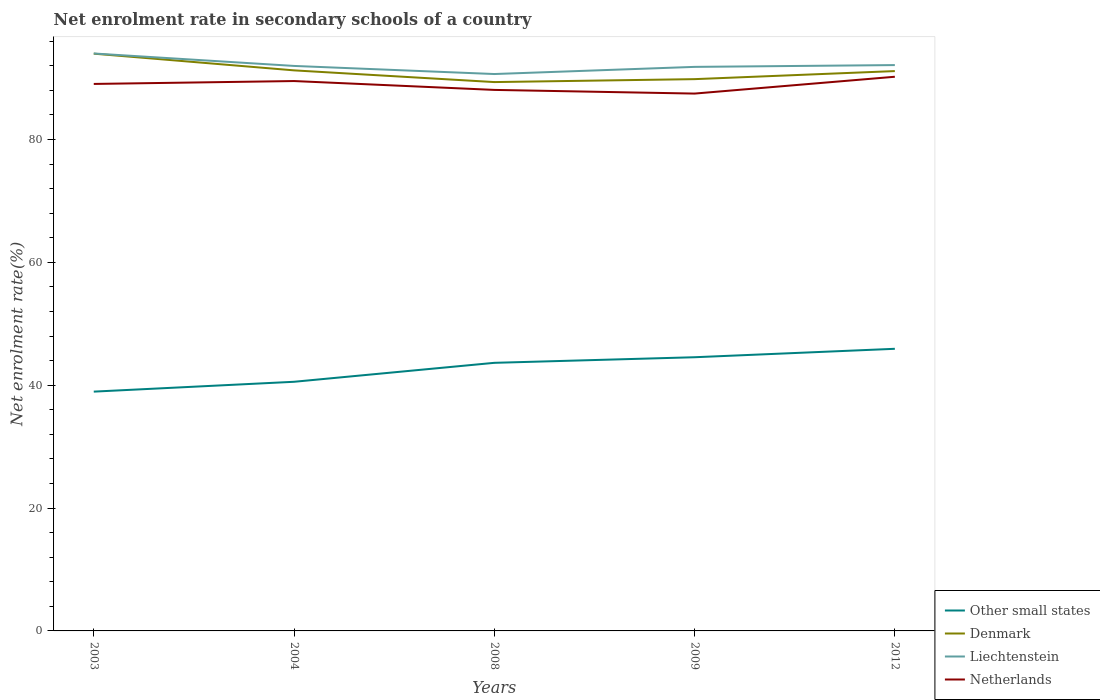How many different coloured lines are there?
Give a very brief answer. 4. Does the line corresponding to Denmark intersect with the line corresponding to Other small states?
Your answer should be very brief. No. Is the number of lines equal to the number of legend labels?
Offer a terse response. Yes. Across all years, what is the maximum net enrolment rate in secondary schools in Netherlands?
Give a very brief answer. 87.48. In which year was the net enrolment rate in secondary schools in Denmark maximum?
Provide a succinct answer. 2008. What is the total net enrolment rate in secondary schools in Netherlands in the graph?
Give a very brief answer. -1.17. What is the difference between the highest and the second highest net enrolment rate in secondary schools in Liechtenstein?
Make the answer very short. 3.35. How many lines are there?
Your answer should be compact. 4. What is the difference between two consecutive major ticks on the Y-axis?
Your answer should be compact. 20. Are the values on the major ticks of Y-axis written in scientific E-notation?
Give a very brief answer. No. Where does the legend appear in the graph?
Offer a terse response. Bottom right. What is the title of the graph?
Provide a succinct answer. Net enrolment rate in secondary schools of a country. Does "Benin" appear as one of the legend labels in the graph?
Your response must be concise. No. What is the label or title of the X-axis?
Give a very brief answer. Years. What is the label or title of the Y-axis?
Give a very brief answer. Net enrolment rate(%). What is the Net enrolment rate(%) of Other small states in 2003?
Give a very brief answer. 38.96. What is the Net enrolment rate(%) of Denmark in 2003?
Offer a very short reply. 93.98. What is the Net enrolment rate(%) in Liechtenstein in 2003?
Offer a terse response. 94.01. What is the Net enrolment rate(%) of Netherlands in 2003?
Ensure brevity in your answer.  89.05. What is the Net enrolment rate(%) in Other small states in 2004?
Your response must be concise. 40.56. What is the Net enrolment rate(%) of Denmark in 2004?
Keep it short and to the point. 91.26. What is the Net enrolment rate(%) of Liechtenstein in 2004?
Offer a terse response. 91.98. What is the Net enrolment rate(%) of Netherlands in 2004?
Keep it short and to the point. 89.52. What is the Net enrolment rate(%) in Other small states in 2008?
Give a very brief answer. 43.64. What is the Net enrolment rate(%) in Denmark in 2008?
Keep it short and to the point. 89.35. What is the Net enrolment rate(%) of Liechtenstein in 2008?
Make the answer very short. 90.66. What is the Net enrolment rate(%) of Netherlands in 2008?
Make the answer very short. 88.08. What is the Net enrolment rate(%) in Other small states in 2009?
Keep it short and to the point. 44.55. What is the Net enrolment rate(%) in Denmark in 2009?
Your answer should be very brief. 89.83. What is the Net enrolment rate(%) of Liechtenstein in 2009?
Offer a terse response. 91.83. What is the Net enrolment rate(%) in Netherlands in 2009?
Provide a succinct answer. 87.48. What is the Net enrolment rate(%) in Other small states in 2012?
Offer a terse response. 45.93. What is the Net enrolment rate(%) of Denmark in 2012?
Provide a short and direct response. 91.14. What is the Net enrolment rate(%) of Liechtenstein in 2012?
Keep it short and to the point. 92.12. What is the Net enrolment rate(%) in Netherlands in 2012?
Ensure brevity in your answer.  90.22. Across all years, what is the maximum Net enrolment rate(%) of Other small states?
Your answer should be compact. 45.93. Across all years, what is the maximum Net enrolment rate(%) in Denmark?
Make the answer very short. 93.98. Across all years, what is the maximum Net enrolment rate(%) of Liechtenstein?
Offer a terse response. 94.01. Across all years, what is the maximum Net enrolment rate(%) in Netherlands?
Your response must be concise. 90.22. Across all years, what is the minimum Net enrolment rate(%) in Other small states?
Offer a terse response. 38.96. Across all years, what is the minimum Net enrolment rate(%) in Denmark?
Ensure brevity in your answer.  89.35. Across all years, what is the minimum Net enrolment rate(%) in Liechtenstein?
Your answer should be very brief. 90.66. Across all years, what is the minimum Net enrolment rate(%) in Netherlands?
Make the answer very short. 87.48. What is the total Net enrolment rate(%) in Other small states in the graph?
Make the answer very short. 213.64. What is the total Net enrolment rate(%) in Denmark in the graph?
Provide a short and direct response. 455.55. What is the total Net enrolment rate(%) in Liechtenstein in the graph?
Ensure brevity in your answer.  460.59. What is the total Net enrolment rate(%) of Netherlands in the graph?
Provide a short and direct response. 444.34. What is the difference between the Net enrolment rate(%) in Other small states in 2003 and that in 2004?
Offer a terse response. -1.6. What is the difference between the Net enrolment rate(%) of Denmark in 2003 and that in 2004?
Your response must be concise. 2.72. What is the difference between the Net enrolment rate(%) of Liechtenstein in 2003 and that in 2004?
Give a very brief answer. 2.03. What is the difference between the Net enrolment rate(%) of Netherlands in 2003 and that in 2004?
Provide a short and direct response. -0.47. What is the difference between the Net enrolment rate(%) of Other small states in 2003 and that in 2008?
Ensure brevity in your answer.  -4.69. What is the difference between the Net enrolment rate(%) of Denmark in 2003 and that in 2008?
Your answer should be compact. 4.63. What is the difference between the Net enrolment rate(%) in Liechtenstein in 2003 and that in 2008?
Make the answer very short. 3.35. What is the difference between the Net enrolment rate(%) in Netherlands in 2003 and that in 2008?
Make the answer very short. 0.97. What is the difference between the Net enrolment rate(%) of Other small states in 2003 and that in 2009?
Provide a short and direct response. -5.6. What is the difference between the Net enrolment rate(%) of Denmark in 2003 and that in 2009?
Provide a short and direct response. 4.15. What is the difference between the Net enrolment rate(%) in Liechtenstein in 2003 and that in 2009?
Make the answer very short. 2.18. What is the difference between the Net enrolment rate(%) in Netherlands in 2003 and that in 2009?
Your answer should be compact. 1.57. What is the difference between the Net enrolment rate(%) in Other small states in 2003 and that in 2012?
Your answer should be very brief. -6.97. What is the difference between the Net enrolment rate(%) in Denmark in 2003 and that in 2012?
Your response must be concise. 2.84. What is the difference between the Net enrolment rate(%) of Liechtenstein in 2003 and that in 2012?
Offer a terse response. 1.89. What is the difference between the Net enrolment rate(%) of Netherlands in 2003 and that in 2012?
Keep it short and to the point. -1.17. What is the difference between the Net enrolment rate(%) in Other small states in 2004 and that in 2008?
Provide a succinct answer. -3.09. What is the difference between the Net enrolment rate(%) in Denmark in 2004 and that in 2008?
Provide a short and direct response. 1.91. What is the difference between the Net enrolment rate(%) of Liechtenstein in 2004 and that in 2008?
Provide a succinct answer. 1.32. What is the difference between the Net enrolment rate(%) in Netherlands in 2004 and that in 2008?
Offer a very short reply. 1.44. What is the difference between the Net enrolment rate(%) in Other small states in 2004 and that in 2009?
Your answer should be very brief. -4. What is the difference between the Net enrolment rate(%) in Denmark in 2004 and that in 2009?
Ensure brevity in your answer.  1.43. What is the difference between the Net enrolment rate(%) of Liechtenstein in 2004 and that in 2009?
Ensure brevity in your answer.  0.15. What is the difference between the Net enrolment rate(%) of Netherlands in 2004 and that in 2009?
Your response must be concise. 2.04. What is the difference between the Net enrolment rate(%) of Other small states in 2004 and that in 2012?
Give a very brief answer. -5.37. What is the difference between the Net enrolment rate(%) of Denmark in 2004 and that in 2012?
Make the answer very short. 0.12. What is the difference between the Net enrolment rate(%) of Liechtenstein in 2004 and that in 2012?
Give a very brief answer. -0.14. What is the difference between the Net enrolment rate(%) of Netherlands in 2004 and that in 2012?
Your answer should be very brief. -0.7. What is the difference between the Net enrolment rate(%) of Other small states in 2008 and that in 2009?
Offer a terse response. -0.91. What is the difference between the Net enrolment rate(%) of Denmark in 2008 and that in 2009?
Ensure brevity in your answer.  -0.48. What is the difference between the Net enrolment rate(%) in Liechtenstein in 2008 and that in 2009?
Your answer should be very brief. -1.17. What is the difference between the Net enrolment rate(%) of Netherlands in 2008 and that in 2009?
Your response must be concise. 0.6. What is the difference between the Net enrolment rate(%) in Other small states in 2008 and that in 2012?
Offer a very short reply. -2.28. What is the difference between the Net enrolment rate(%) in Denmark in 2008 and that in 2012?
Provide a short and direct response. -1.79. What is the difference between the Net enrolment rate(%) of Liechtenstein in 2008 and that in 2012?
Your answer should be very brief. -1.46. What is the difference between the Net enrolment rate(%) in Netherlands in 2008 and that in 2012?
Make the answer very short. -2.14. What is the difference between the Net enrolment rate(%) of Other small states in 2009 and that in 2012?
Offer a terse response. -1.38. What is the difference between the Net enrolment rate(%) of Denmark in 2009 and that in 2012?
Provide a succinct answer. -1.31. What is the difference between the Net enrolment rate(%) in Liechtenstein in 2009 and that in 2012?
Ensure brevity in your answer.  -0.29. What is the difference between the Net enrolment rate(%) in Netherlands in 2009 and that in 2012?
Make the answer very short. -2.74. What is the difference between the Net enrolment rate(%) of Other small states in 2003 and the Net enrolment rate(%) of Denmark in 2004?
Offer a very short reply. -52.3. What is the difference between the Net enrolment rate(%) of Other small states in 2003 and the Net enrolment rate(%) of Liechtenstein in 2004?
Give a very brief answer. -53.02. What is the difference between the Net enrolment rate(%) of Other small states in 2003 and the Net enrolment rate(%) of Netherlands in 2004?
Ensure brevity in your answer.  -50.56. What is the difference between the Net enrolment rate(%) of Denmark in 2003 and the Net enrolment rate(%) of Liechtenstein in 2004?
Ensure brevity in your answer.  2. What is the difference between the Net enrolment rate(%) of Denmark in 2003 and the Net enrolment rate(%) of Netherlands in 2004?
Your answer should be very brief. 4.46. What is the difference between the Net enrolment rate(%) of Liechtenstein in 2003 and the Net enrolment rate(%) of Netherlands in 2004?
Offer a very short reply. 4.49. What is the difference between the Net enrolment rate(%) in Other small states in 2003 and the Net enrolment rate(%) in Denmark in 2008?
Provide a short and direct response. -50.39. What is the difference between the Net enrolment rate(%) of Other small states in 2003 and the Net enrolment rate(%) of Liechtenstein in 2008?
Give a very brief answer. -51.7. What is the difference between the Net enrolment rate(%) of Other small states in 2003 and the Net enrolment rate(%) of Netherlands in 2008?
Ensure brevity in your answer.  -49.12. What is the difference between the Net enrolment rate(%) of Denmark in 2003 and the Net enrolment rate(%) of Liechtenstein in 2008?
Keep it short and to the point. 3.32. What is the difference between the Net enrolment rate(%) of Denmark in 2003 and the Net enrolment rate(%) of Netherlands in 2008?
Ensure brevity in your answer.  5.9. What is the difference between the Net enrolment rate(%) of Liechtenstein in 2003 and the Net enrolment rate(%) of Netherlands in 2008?
Give a very brief answer. 5.93. What is the difference between the Net enrolment rate(%) of Other small states in 2003 and the Net enrolment rate(%) of Denmark in 2009?
Your response must be concise. -50.87. What is the difference between the Net enrolment rate(%) of Other small states in 2003 and the Net enrolment rate(%) of Liechtenstein in 2009?
Your response must be concise. -52.87. What is the difference between the Net enrolment rate(%) of Other small states in 2003 and the Net enrolment rate(%) of Netherlands in 2009?
Provide a succinct answer. -48.52. What is the difference between the Net enrolment rate(%) in Denmark in 2003 and the Net enrolment rate(%) in Liechtenstein in 2009?
Ensure brevity in your answer.  2.15. What is the difference between the Net enrolment rate(%) of Denmark in 2003 and the Net enrolment rate(%) of Netherlands in 2009?
Provide a short and direct response. 6.5. What is the difference between the Net enrolment rate(%) in Liechtenstein in 2003 and the Net enrolment rate(%) in Netherlands in 2009?
Your answer should be very brief. 6.53. What is the difference between the Net enrolment rate(%) of Other small states in 2003 and the Net enrolment rate(%) of Denmark in 2012?
Your answer should be very brief. -52.18. What is the difference between the Net enrolment rate(%) in Other small states in 2003 and the Net enrolment rate(%) in Liechtenstein in 2012?
Ensure brevity in your answer.  -53.16. What is the difference between the Net enrolment rate(%) in Other small states in 2003 and the Net enrolment rate(%) in Netherlands in 2012?
Provide a succinct answer. -51.26. What is the difference between the Net enrolment rate(%) in Denmark in 2003 and the Net enrolment rate(%) in Liechtenstein in 2012?
Give a very brief answer. 1.86. What is the difference between the Net enrolment rate(%) of Denmark in 2003 and the Net enrolment rate(%) of Netherlands in 2012?
Offer a very short reply. 3.76. What is the difference between the Net enrolment rate(%) of Liechtenstein in 2003 and the Net enrolment rate(%) of Netherlands in 2012?
Your answer should be very brief. 3.79. What is the difference between the Net enrolment rate(%) in Other small states in 2004 and the Net enrolment rate(%) in Denmark in 2008?
Make the answer very short. -48.79. What is the difference between the Net enrolment rate(%) of Other small states in 2004 and the Net enrolment rate(%) of Liechtenstein in 2008?
Offer a very short reply. -50.1. What is the difference between the Net enrolment rate(%) of Other small states in 2004 and the Net enrolment rate(%) of Netherlands in 2008?
Offer a very short reply. -47.52. What is the difference between the Net enrolment rate(%) in Denmark in 2004 and the Net enrolment rate(%) in Liechtenstein in 2008?
Give a very brief answer. 0.6. What is the difference between the Net enrolment rate(%) of Denmark in 2004 and the Net enrolment rate(%) of Netherlands in 2008?
Provide a short and direct response. 3.18. What is the difference between the Net enrolment rate(%) in Liechtenstein in 2004 and the Net enrolment rate(%) in Netherlands in 2008?
Keep it short and to the point. 3.9. What is the difference between the Net enrolment rate(%) of Other small states in 2004 and the Net enrolment rate(%) of Denmark in 2009?
Offer a terse response. -49.27. What is the difference between the Net enrolment rate(%) of Other small states in 2004 and the Net enrolment rate(%) of Liechtenstein in 2009?
Keep it short and to the point. -51.27. What is the difference between the Net enrolment rate(%) of Other small states in 2004 and the Net enrolment rate(%) of Netherlands in 2009?
Make the answer very short. -46.92. What is the difference between the Net enrolment rate(%) in Denmark in 2004 and the Net enrolment rate(%) in Liechtenstein in 2009?
Your answer should be very brief. -0.57. What is the difference between the Net enrolment rate(%) of Denmark in 2004 and the Net enrolment rate(%) of Netherlands in 2009?
Your answer should be compact. 3.78. What is the difference between the Net enrolment rate(%) of Liechtenstein in 2004 and the Net enrolment rate(%) of Netherlands in 2009?
Your answer should be very brief. 4.5. What is the difference between the Net enrolment rate(%) in Other small states in 2004 and the Net enrolment rate(%) in Denmark in 2012?
Give a very brief answer. -50.58. What is the difference between the Net enrolment rate(%) of Other small states in 2004 and the Net enrolment rate(%) of Liechtenstein in 2012?
Give a very brief answer. -51.56. What is the difference between the Net enrolment rate(%) of Other small states in 2004 and the Net enrolment rate(%) of Netherlands in 2012?
Your response must be concise. -49.66. What is the difference between the Net enrolment rate(%) of Denmark in 2004 and the Net enrolment rate(%) of Liechtenstein in 2012?
Provide a succinct answer. -0.86. What is the difference between the Net enrolment rate(%) of Denmark in 2004 and the Net enrolment rate(%) of Netherlands in 2012?
Provide a succinct answer. 1.04. What is the difference between the Net enrolment rate(%) in Liechtenstein in 2004 and the Net enrolment rate(%) in Netherlands in 2012?
Make the answer very short. 1.76. What is the difference between the Net enrolment rate(%) in Other small states in 2008 and the Net enrolment rate(%) in Denmark in 2009?
Your answer should be very brief. -46.18. What is the difference between the Net enrolment rate(%) in Other small states in 2008 and the Net enrolment rate(%) in Liechtenstein in 2009?
Make the answer very short. -48.18. What is the difference between the Net enrolment rate(%) in Other small states in 2008 and the Net enrolment rate(%) in Netherlands in 2009?
Give a very brief answer. -43.83. What is the difference between the Net enrolment rate(%) in Denmark in 2008 and the Net enrolment rate(%) in Liechtenstein in 2009?
Offer a terse response. -2.48. What is the difference between the Net enrolment rate(%) in Denmark in 2008 and the Net enrolment rate(%) in Netherlands in 2009?
Your answer should be compact. 1.87. What is the difference between the Net enrolment rate(%) in Liechtenstein in 2008 and the Net enrolment rate(%) in Netherlands in 2009?
Your answer should be compact. 3.18. What is the difference between the Net enrolment rate(%) in Other small states in 2008 and the Net enrolment rate(%) in Denmark in 2012?
Make the answer very short. -47.5. What is the difference between the Net enrolment rate(%) in Other small states in 2008 and the Net enrolment rate(%) in Liechtenstein in 2012?
Your answer should be very brief. -48.47. What is the difference between the Net enrolment rate(%) in Other small states in 2008 and the Net enrolment rate(%) in Netherlands in 2012?
Your answer should be very brief. -46.57. What is the difference between the Net enrolment rate(%) in Denmark in 2008 and the Net enrolment rate(%) in Liechtenstein in 2012?
Make the answer very short. -2.77. What is the difference between the Net enrolment rate(%) of Denmark in 2008 and the Net enrolment rate(%) of Netherlands in 2012?
Keep it short and to the point. -0.87. What is the difference between the Net enrolment rate(%) of Liechtenstein in 2008 and the Net enrolment rate(%) of Netherlands in 2012?
Offer a very short reply. 0.44. What is the difference between the Net enrolment rate(%) in Other small states in 2009 and the Net enrolment rate(%) in Denmark in 2012?
Give a very brief answer. -46.59. What is the difference between the Net enrolment rate(%) of Other small states in 2009 and the Net enrolment rate(%) of Liechtenstein in 2012?
Keep it short and to the point. -47.56. What is the difference between the Net enrolment rate(%) in Other small states in 2009 and the Net enrolment rate(%) in Netherlands in 2012?
Ensure brevity in your answer.  -45.66. What is the difference between the Net enrolment rate(%) of Denmark in 2009 and the Net enrolment rate(%) of Liechtenstein in 2012?
Keep it short and to the point. -2.29. What is the difference between the Net enrolment rate(%) in Denmark in 2009 and the Net enrolment rate(%) in Netherlands in 2012?
Provide a succinct answer. -0.39. What is the difference between the Net enrolment rate(%) of Liechtenstein in 2009 and the Net enrolment rate(%) of Netherlands in 2012?
Make the answer very short. 1.61. What is the average Net enrolment rate(%) in Other small states per year?
Offer a terse response. 42.73. What is the average Net enrolment rate(%) in Denmark per year?
Keep it short and to the point. 91.11. What is the average Net enrolment rate(%) of Liechtenstein per year?
Give a very brief answer. 92.12. What is the average Net enrolment rate(%) in Netherlands per year?
Your answer should be very brief. 88.87. In the year 2003, what is the difference between the Net enrolment rate(%) of Other small states and Net enrolment rate(%) of Denmark?
Provide a short and direct response. -55.02. In the year 2003, what is the difference between the Net enrolment rate(%) in Other small states and Net enrolment rate(%) in Liechtenstein?
Ensure brevity in your answer.  -55.05. In the year 2003, what is the difference between the Net enrolment rate(%) in Other small states and Net enrolment rate(%) in Netherlands?
Make the answer very short. -50.09. In the year 2003, what is the difference between the Net enrolment rate(%) of Denmark and Net enrolment rate(%) of Liechtenstein?
Make the answer very short. -0.03. In the year 2003, what is the difference between the Net enrolment rate(%) of Denmark and Net enrolment rate(%) of Netherlands?
Keep it short and to the point. 4.93. In the year 2003, what is the difference between the Net enrolment rate(%) in Liechtenstein and Net enrolment rate(%) in Netherlands?
Your answer should be very brief. 4.96. In the year 2004, what is the difference between the Net enrolment rate(%) of Other small states and Net enrolment rate(%) of Denmark?
Your response must be concise. -50.7. In the year 2004, what is the difference between the Net enrolment rate(%) in Other small states and Net enrolment rate(%) in Liechtenstein?
Keep it short and to the point. -51.42. In the year 2004, what is the difference between the Net enrolment rate(%) in Other small states and Net enrolment rate(%) in Netherlands?
Provide a short and direct response. -48.96. In the year 2004, what is the difference between the Net enrolment rate(%) of Denmark and Net enrolment rate(%) of Liechtenstein?
Keep it short and to the point. -0.72. In the year 2004, what is the difference between the Net enrolment rate(%) of Denmark and Net enrolment rate(%) of Netherlands?
Offer a very short reply. 1.74. In the year 2004, what is the difference between the Net enrolment rate(%) in Liechtenstein and Net enrolment rate(%) in Netherlands?
Ensure brevity in your answer.  2.46. In the year 2008, what is the difference between the Net enrolment rate(%) in Other small states and Net enrolment rate(%) in Denmark?
Your response must be concise. -45.71. In the year 2008, what is the difference between the Net enrolment rate(%) in Other small states and Net enrolment rate(%) in Liechtenstein?
Make the answer very short. -47.01. In the year 2008, what is the difference between the Net enrolment rate(%) in Other small states and Net enrolment rate(%) in Netherlands?
Ensure brevity in your answer.  -44.43. In the year 2008, what is the difference between the Net enrolment rate(%) of Denmark and Net enrolment rate(%) of Liechtenstein?
Provide a short and direct response. -1.31. In the year 2008, what is the difference between the Net enrolment rate(%) in Denmark and Net enrolment rate(%) in Netherlands?
Make the answer very short. 1.27. In the year 2008, what is the difference between the Net enrolment rate(%) of Liechtenstein and Net enrolment rate(%) of Netherlands?
Your answer should be compact. 2.58. In the year 2009, what is the difference between the Net enrolment rate(%) in Other small states and Net enrolment rate(%) in Denmark?
Your response must be concise. -45.27. In the year 2009, what is the difference between the Net enrolment rate(%) in Other small states and Net enrolment rate(%) in Liechtenstein?
Your answer should be compact. -47.27. In the year 2009, what is the difference between the Net enrolment rate(%) of Other small states and Net enrolment rate(%) of Netherlands?
Offer a terse response. -42.92. In the year 2009, what is the difference between the Net enrolment rate(%) of Denmark and Net enrolment rate(%) of Liechtenstein?
Make the answer very short. -2. In the year 2009, what is the difference between the Net enrolment rate(%) in Denmark and Net enrolment rate(%) in Netherlands?
Offer a very short reply. 2.35. In the year 2009, what is the difference between the Net enrolment rate(%) of Liechtenstein and Net enrolment rate(%) of Netherlands?
Provide a short and direct response. 4.35. In the year 2012, what is the difference between the Net enrolment rate(%) in Other small states and Net enrolment rate(%) in Denmark?
Make the answer very short. -45.21. In the year 2012, what is the difference between the Net enrolment rate(%) of Other small states and Net enrolment rate(%) of Liechtenstein?
Keep it short and to the point. -46.19. In the year 2012, what is the difference between the Net enrolment rate(%) of Other small states and Net enrolment rate(%) of Netherlands?
Ensure brevity in your answer.  -44.29. In the year 2012, what is the difference between the Net enrolment rate(%) in Denmark and Net enrolment rate(%) in Liechtenstein?
Offer a very short reply. -0.98. In the year 2012, what is the difference between the Net enrolment rate(%) of Denmark and Net enrolment rate(%) of Netherlands?
Your answer should be very brief. 0.92. In the year 2012, what is the difference between the Net enrolment rate(%) of Liechtenstein and Net enrolment rate(%) of Netherlands?
Your answer should be compact. 1.9. What is the ratio of the Net enrolment rate(%) of Other small states in 2003 to that in 2004?
Provide a short and direct response. 0.96. What is the ratio of the Net enrolment rate(%) of Denmark in 2003 to that in 2004?
Your answer should be compact. 1.03. What is the ratio of the Net enrolment rate(%) of Netherlands in 2003 to that in 2004?
Keep it short and to the point. 0.99. What is the ratio of the Net enrolment rate(%) in Other small states in 2003 to that in 2008?
Give a very brief answer. 0.89. What is the ratio of the Net enrolment rate(%) of Denmark in 2003 to that in 2008?
Offer a very short reply. 1.05. What is the ratio of the Net enrolment rate(%) in Liechtenstein in 2003 to that in 2008?
Ensure brevity in your answer.  1.04. What is the ratio of the Net enrolment rate(%) in Other small states in 2003 to that in 2009?
Ensure brevity in your answer.  0.87. What is the ratio of the Net enrolment rate(%) of Denmark in 2003 to that in 2009?
Your response must be concise. 1.05. What is the ratio of the Net enrolment rate(%) in Liechtenstein in 2003 to that in 2009?
Your answer should be compact. 1.02. What is the ratio of the Net enrolment rate(%) of Other small states in 2003 to that in 2012?
Ensure brevity in your answer.  0.85. What is the ratio of the Net enrolment rate(%) in Denmark in 2003 to that in 2012?
Your answer should be compact. 1.03. What is the ratio of the Net enrolment rate(%) of Liechtenstein in 2003 to that in 2012?
Give a very brief answer. 1.02. What is the ratio of the Net enrolment rate(%) in Netherlands in 2003 to that in 2012?
Your answer should be compact. 0.99. What is the ratio of the Net enrolment rate(%) of Other small states in 2004 to that in 2008?
Ensure brevity in your answer.  0.93. What is the ratio of the Net enrolment rate(%) in Denmark in 2004 to that in 2008?
Offer a terse response. 1.02. What is the ratio of the Net enrolment rate(%) of Liechtenstein in 2004 to that in 2008?
Your response must be concise. 1.01. What is the ratio of the Net enrolment rate(%) in Netherlands in 2004 to that in 2008?
Your answer should be compact. 1.02. What is the ratio of the Net enrolment rate(%) of Other small states in 2004 to that in 2009?
Provide a short and direct response. 0.91. What is the ratio of the Net enrolment rate(%) of Denmark in 2004 to that in 2009?
Provide a succinct answer. 1.02. What is the ratio of the Net enrolment rate(%) of Netherlands in 2004 to that in 2009?
Provide a succinct answer. 1.02. What is the ratio of the Net enrolment rate(%) of Other small states in 2004 to that in 2012?
Your answer should be very brief. 0.88. What is the ratio of the Net enrolment rate(%) in Denmark in 2004 to that in 2012?
Give a very brief answer. 1. What is the ratio of the Net enrolment rate(%) in Netherlands in 2004 to that in 2012?
Your response must be concise. 0.99. What is the ratio of the Net enrolment rate(%) in Other small states in 2008 to that in 2009?
Offer a very short reply. 0.98. What is the ratio of the Net enrolment rate(%) in Denmark in 2008 to that in 2009?
Offer a terse response. 0.99. What is the ratio of the Net enrolment rate(%) of Liechtenstein in 2008 to that in 2009?
Your answer should be very brief. 0.99. What is the ratio of the Net enrolment rate(%) in Netherlands in 2008 to that in 2009?
Offer a very short reply. 1.01. What is the ratio of the Net enrolment rate(%) in Other small states in 2008 to that in 2012?
Make the answer very short. 0.95. What is the ratio of the Net enrolment rate(%) of Denmark in 2008 to that in 2012?
Make the answer very short. 0.98. What is the ratio of the Net enrolment rate(%) in Liechtenstein in 2008 to that in 2012?
Give a very brief answer. 0.98. What is the ratio of the Net enrolment rate(%) in Netherlands in 2008 to that in 2012?
Your response must be concise. 0.98. What is the ratio of the Net enrolment rate(%) of Other small states in 2009 to that in 2012?
Provide a short and direct response. 0.97. What is the ratio of the Net enrolment rate(%) of Denmark in 2009 to that in 2012?
Provide a succinct answer. 0.99. What is the ratio of the Net enrolment rate(%) in Liechtenstein in 2009 to that in 2012?
Provide a short and direct response. 1. What is the ratio of the Net enrolment rate(%) of Netherlands in 2009 to that in 2012?
Ensure brevity in your answer.  0.97. What is the difference between the highest and the second highest Net enrolment rate(%) in Other small states?
Your answer should be compact. 1.38. What is the difference between the highest and the second highest Net enrolment rate(%) in Denmark?
Your response must be concise. 2.72. What is the difference between the highest and the second highest Net enrolment rate(%) in Liechtenstein?
Your answer should be compact. 1.89. What is the difference between the highest and the second highest Net enrolment rate(%) in Netherlands?
Provide a succinct answer. 0.7. What is the difference between the highest and the lowest Net enrolment rate(%) in Other small states?
Your response must be concise. 6.97. What is the difference between the highest and the lowest Net enrolment rate(%) in Denmark?
Make the answer very short. 4.63. What is the difference between the highest and the lowest Net enrolment rate(%) in Liechtenstein?
Keep it short and to the point. 3.35. What is the difference between the highest and the lowest Net enrolment rate(%) in Netherlands?
Give a very brief answer. 2.74. 